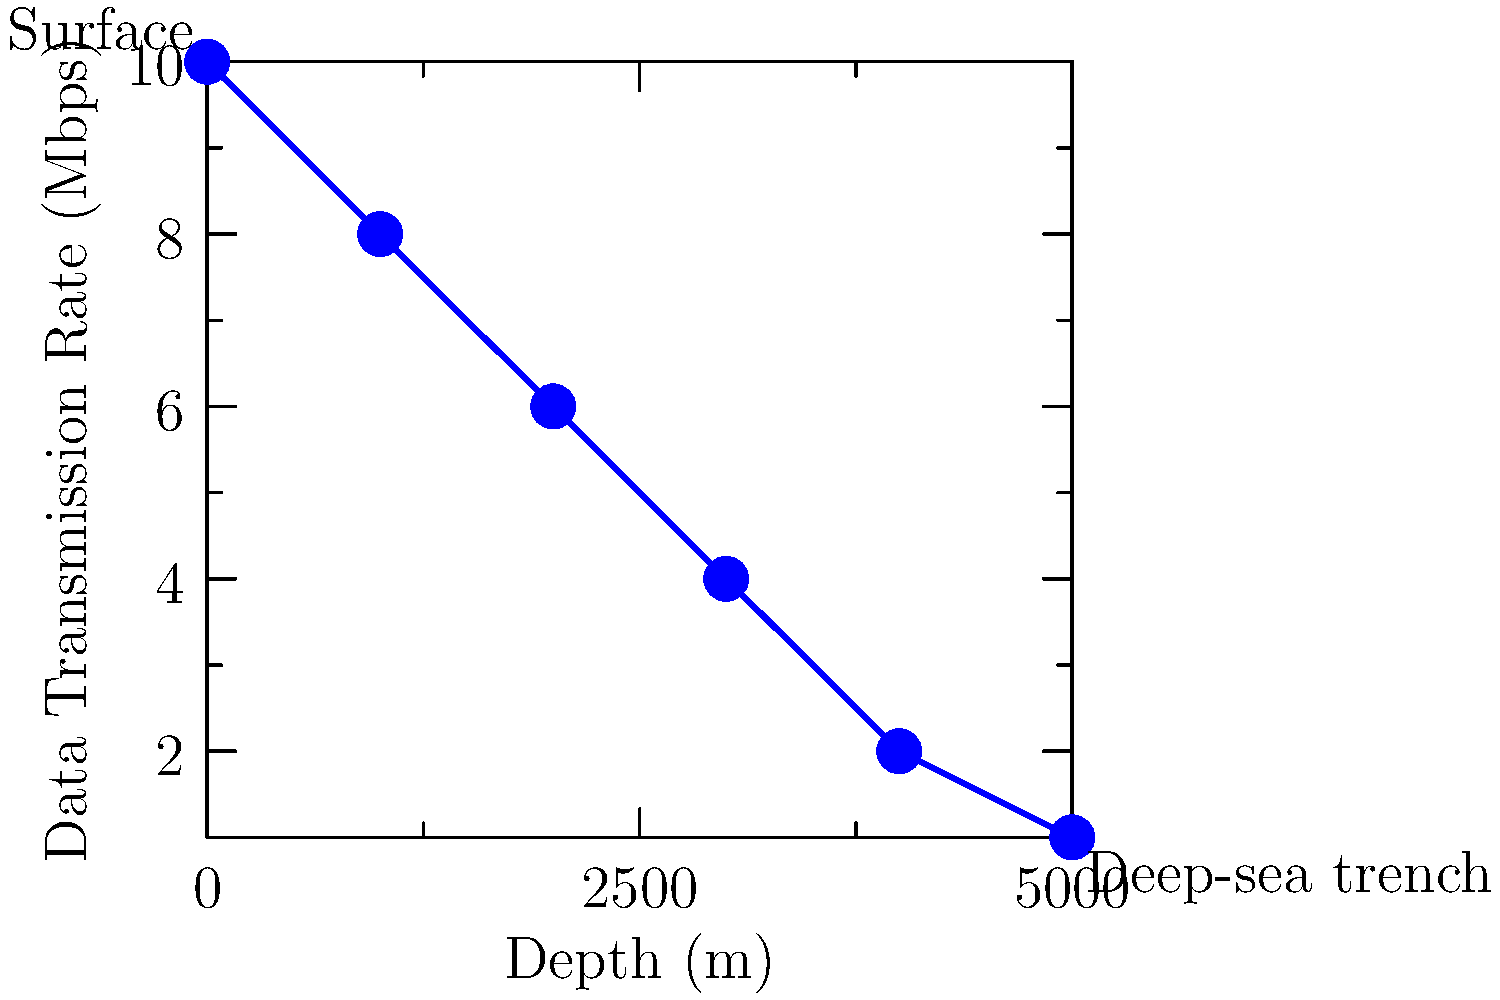Based on the graph showing the relationship between depth and data transmission rates for ROVs, what is the approximate data transmission rate at a depth of 3500 meters? To determine the approximate data transmission rate at 3500 meters depth, we need to follow these steps:

1. Observe that the graph shows a linear relationship between depth and data transmission rate.
2. Identify the two closest known points on the graph:
   - At 3000m depth, the rate is 4 Mbps
   - At 4000m depth, the rate is 2 Mbps
3. Calculate the rate of change between these two points:
   $\frac{\text{Change in rate}}{\text{Change in depth}} = \frac{4 \text{ Mbps} - 2 \text{ Mbps}}{3000 \text{ m} - 4000 \text{ m}} = \frac{2 \text{ Mbps}}{1000 \text{ m}} = 0.002 \text{ Mbps/m}$
4. The target depth (3500m) is halfway between 3000m and 4000m, so we can interpolate:
   Rate at 3500m = Rate at 3000m - (0.002 Mbps/m × 500m)
   $= 4 \text{ Mbps} - 1 \text{ Mbps} = 3 \text{ Mbps}$

Therefore, the approximate data transmission rate at a depth of 3500 meters is 3 Mbps.
Answer: 3 Mbps 